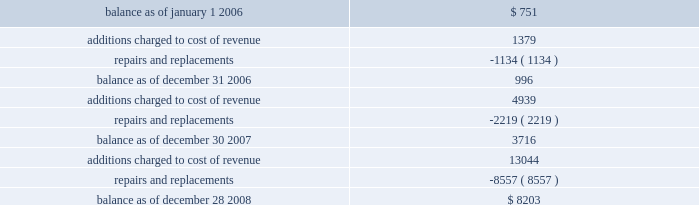Utilized .
In accordance with sfas no .
144 , accounting for the impairment or disposal of long-lived assets , a non-cash impairment charge of $ 4.1 million was recorded in the second quarter of fiscal 2008 for the excess machinery .
This charge is included as a separate line item in the company 2019s consolidated statement of operations .
There was no change to useful lives and related depreciation expense of the remaining assets as the company believes these estimates are currently reflective of the period the assets will be used in operations .
Warranties the company generally provides a one-year warranty on sequencing , genotyping and gene expression systems .
At the time revenue is recognized , the company establishes an accrual for estimated warranty expenses associated with system sales .
This expense is recorded as a component of cost of product revenue .
Estimated warranty expenses associated with extended maintenance contracts are recorded as cost of revenue ratably over the term of the maintenance contract .
Changes in the company 2019s reserve for product warranties from january 1 , 2006 through december 28 , 2008 are as follows ( in thousands ) : .
Convertible senior notes on february 16 , 2007 , the company issued $ 400.0 million principal amount of 0.625% ( 0.625 % ) convertible senior notes due 2014 ( the notes ) , which included the exercise of the initial purchasers 2019 option to purchase up to an additional $ 50.0 million aggregate principal amount of notes .
The net proceeds from the offering , after deducting the initial purchasers 2019 discount and offering expenses , were $ 390.3 million .
The company will pay 0.625% ( 0.625 % ) interest per annum on the principal amount of the notes , payable semi-annually in arrears in cash on february 15 and august 15 of each year .
The company made interest payments of $ 1.3 million and $ 1.2 million on february 15 , 2008 and august 15 , 2008 , respectively .
The notes mature on february 15 , the notes will be convertible into cash and , if applicable , shares of the company 2019s common stock , $ 0.01 par value per share , based on a conversion rate , subject to adjustment , of 45.8058 shares per $ 1000 principal amount of notes ( which represents a conversion price of $ 21.83 per share ) , only in the following circumstances and to the following extent : ( 1 ) during the five business-day period after any five consecutive trading period ( the measurement period ) in which the trading price per note for each day of such measurement period was less than 97% ( 97 % ) of the product of the last reported sale price of the company 2019s common stock and the conversion rate on each such day ; ( 2 ) during any calendar quarter after the calendar quarter ending march 30 , 2007 , if the last reported sale price of the company 2019s common stock for 20 or more trading days in a period of 30 consecutive trading days ending on the last trading day of the immediately illumina , inc .
Notes to consolidated financial statements 2014 ( continued ) .
What was the percent of the change in the company 2019s reserve for product warranties in , 2006? 
Rationale: the company 2019s reserve for product warranties in , 2006 increased by 32.6%
Computations: ((996 - 751) / 751)
Answer: 0.32623. Utilized .
In accordance with sfas no .
144 , accounting for the impairment or disposal of long-lived assets , a non-cash impairment charge of $ 4.1 million was recorded in the second quarter of fiscal 2008 for the excess machinery .
This charge is included as a separate line item in the company 2019s consolidated statement of operations .
There was no change to useful lives and related depreciation expense of the remaining assets as the company believes these estimates are currently reflective of the period the assets will be used in operations .
Warranties the company generally provides a one-year warranty on sequencing , genotyping and gene expression systems .
At the time revenue is recognized , the company establishes an accrual for estimated warranty expenses associated with system sales .
This expense is recorded as a component of cost of product revenue .
Estimated warranty expenses associated with extended maintenance contracts are recorded as cost of revenue ratably over the term of the maintenance contract .
Changes in the company 2019s reserve for product warranties from january 1 , 2006 through december 28 , 2008 are as follows ( in thousands ) : .
Convertible senior notes on february 16 , 2007 , the company issued $ 400.0 million principal amount of 0.625% ( 0.625 % ) convertible senior notes due 2014 ( the notes ) , which included the exercise of the initial purchasers 2019 option to purchase up to an additional $ 50.0 million aggregate principal amount of notes .
The net proceeds from the offering , after deducting the initial purchasers 2019 discount and offering expenses , were $ 390.3 million .
The company will pay 0.625% ( 0.625 % ) interest per annum on the principal amount of the notes , payable semi-annually in arrears in cash on february 15 and august 15 of each year .
The company made interest payments of $ 1.3 million and $ 1.2 million on february 15 , 2008 and august 15 , 2008 , respectively .
The notes mature on february 15 , the notes will be convertible into cash and , if applicable , shares of the company 2019s common stock , $ 0.01 par value per share , based on a conversion rate , subject to adjustment , of 45.8058 shares per $ 1000 principal amount of notes ( which represents a conversion price of $ 21.83 per share ) , only in the following circumstances and to the following extent : ( 1 ) during the five business-day period after any five consecutive trading period ( the measurement period ) in which the trading price per note for each day of such measurement period was less than 97% ( 97 % ) of the product of the last reported sale price of the company 2019s common stock and the conversion rate on each such day ; ( 2 ) during any calendar quarter after the calendar quarter ending march 30 , 2007 , if the last reported sale price of the company 2019s common stock for 20 or more trading days in a period of 30 consecutive trading days ending on the last trading day of the immediately illumina , inc .
Notes to consolidated financial statements 2014 ( continued ) .
What was the percentage change in the reserve for product warranties from december 31 2006 to december 30 2007? 
Computations: ((3716 - 996) / 996)
Answer: 2.73092. 